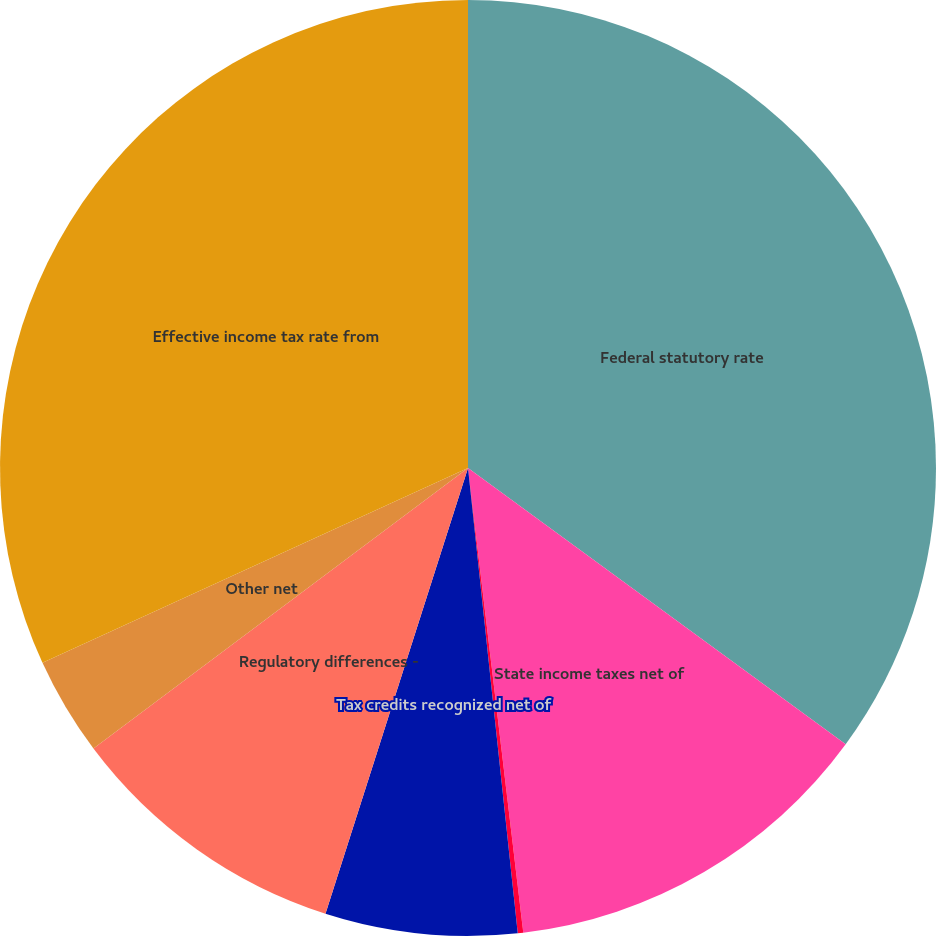<chart> <loc_0><loc_0><loc_500><loc_500><pie_chart><fcel>Federal statutory rate<fcel>State income taxes net of<fcel>Life insurance policies<fcel>Tax credits recognized net of<fcel>Regulatory differences -<fcel>Other net<fcel>Effective income tax rate from<nl><fcel>35.05%<fcel>13.06%<fcel>0.19%<fcel>6.62%<fcel>9.84%<fcel>3.4%<fcel>31.83%<nl></chart> 